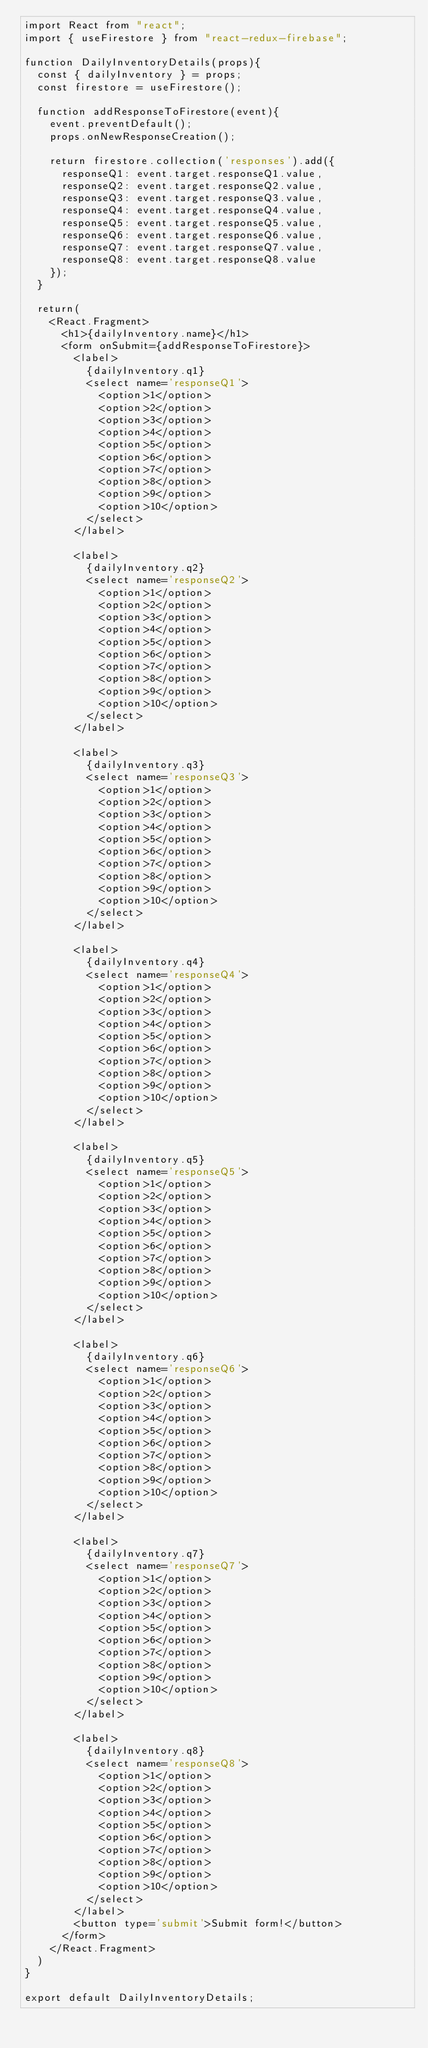Convert code to text. <code><loc_0><loc_0><loc_500><loc_500><_JavaScript_>import React from "react";
import { useFirestore } from "react-redux-firebase";

function DailyInventoryDetails(props){
  const { dailyInventory } = props;
  const firestore = useFirestore();

  function addResponseToFirestore(event){
    event.preventDefault();
    props.onNewResponseCreation();

    return firestore.collection('responses').add({
      responseQ1: event.target.responseQ1.value,
      responseQ2: event.target.responseQ2.value,
      responseQ3: event.target.responseQ3.value,
      responseQ4: event.target.responseQ4.value,
      responseQ5: event.target.responseQ5.value,
      responseQ6: event.target.responseQ6.value,
      responseQ7: event.target.responseQ7.value,
      responseQ8: event.target.responseQ8.value
    });
  }

  return(
    <React.Fragment>
      <h1>{dailyInventory.name}</h1>
      <form onSubmit={addResponseToFirestore}>
        <label>
          {dailyInventory.q1}
          <select name='responseQ1'>
            <option>1</option>
            <option>2</option>
            <option>3</option>
            <option>4</option>
            <option>5</option>
            <option>6</option>
            <option>7</option>
            <option>8</option>
            <option>9</option>
            <option>10</option>
          </select>
        </label>

        <label>
          {dailyInventory.q2}
          <select name='responseQ2'>
            <option>1</option>
            <option>2</option>
            <option>3</option>
            <option>4</option>
            <option>5</option>
            <option>6</option>
            <option>7</option>
            <option>8</option>
            <option>9</option>
            <option>10</option>
          </select>
        </label>

        <label>
          {dailyInventory.q3}
          <select name='responseQ3'>
            <option>1</option>
            <option>2</option>
            <option>3</option>
            <option>4</option>
            <option>5</option>
            <option>6</option>
            <option>7</option>
            <option>8</option>
            <option>9</option>
            <option>10</option>
          </select>
        </label>

        <label>
          {dailyInventory.q4}
          <select name='responseQ4'>
            <option>1</option>
            <option>2</option>
            <option>3</option>
            <option>4</option>
            <option>5</option>
            <option>6</option>
            <option>7</option>
            <option>8</option>
            <option>9</option>
            <option>10</option>
          </select>
        </label>

        <label>
          {dailyInventory.q5}
          <select name='responseQ5'>
            <option>1</option>
            <option>2</option>
            <option>3</option>
            <option>4</option>
            <option>5</option>
            <option>6</option>
            <option>7</option>
            <option>8</option>
            <option>9</option>
            <option>10</option>
          </select>
        </label>

        <label>
          {dailyInventory.q6}
          <select name='responseQ6'>
            <option>1</option>
            <option>2</option>
            <option>3</option>
            <option>4</option>
            <option>5</option>
            <option>6</option>
            <option>7</option>
            <option>8</option>
            <option>9</option>
            <option>10</option>
          </select>
        </label>

        <label>
          {dailyInventory.q7}
          <select name='responseQ7'>
            <option>1</option>
            <option>2</option>
            <option>3</option>
            <option>4</option>
            <option>5</option>
            <option>6</option>
            <option>7</option>
            <option>8</option>
            <option>9</option>
            <option>10</option>
          </select>
        </label>

        <label>
          {dailyInventory.q8}
          <select name='responseQ8'>
            <option>1</option>
            <option>2</option>
            <option>3</option>
            <option>4</option>
            <option>5</option>
            <option>6</option>
            <option>7</option>
            <option>8</option>
            <option>9</option>
            <option>10</option>
          </select>
        </label>
        <button type='submit'>Submit form!</button>
      </form>
    </React.Fragment>
  )
}

export default DailyInventoryDetails;</code> 